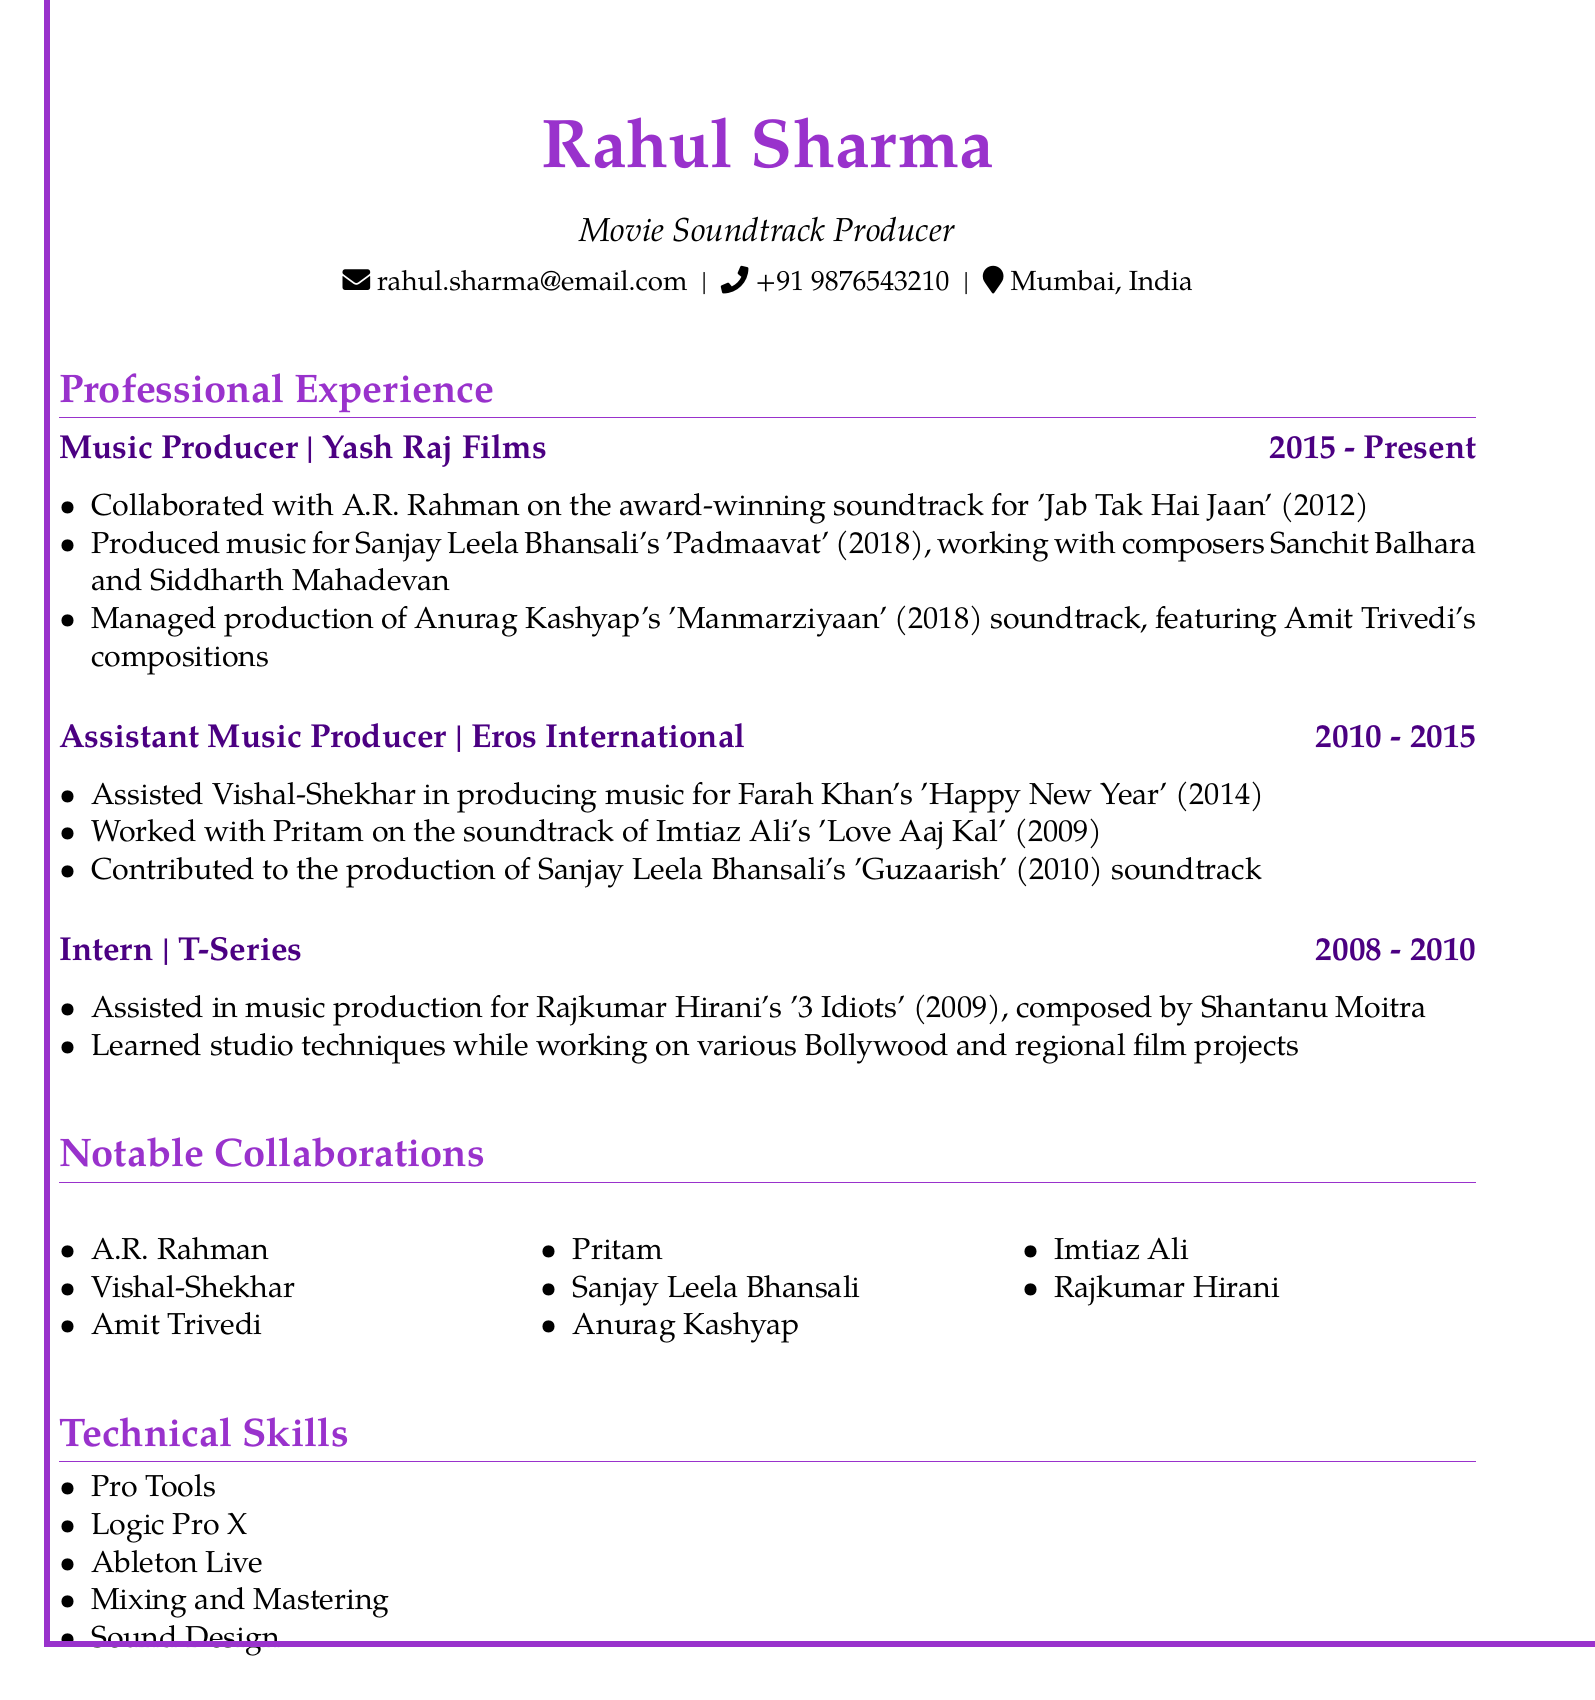What is the current position of Rahul Sharma? The current position is listed as Music Producer.
Answer: Music Producer In which company does Rahul Sharma work? The document states that he works at Yash Raj Films.
Answer: Yash Raj Films What is the duration of Rahul Sharma's role at Eros International? The document specifies the duration is from 2010 to 2015.
Answer: 2010 - 2015 Which award-winning soundtrack did Rahul collaborate on with A.R. Rahman? The document mentions 'Jab Tak Hai Jaan' as the soundtrack he worked on.
Answer: Jab Tak Hai Jaan Who composed the soundtrack for '3 Idiots'? According to the document, the composer is Shantanu Moitra.
Answer: Shantanu Moitra What notable collaboration is mentioned in the context of Sanjay Leela Bhansali? The document highlights that he collaborated with Sanjay Leela Bhansali on the soundtrack for 'Padmaavat'.
Answer: Padmaavat How many notable collaborations are listed in the document? The document lists eight notable collaborations.
Answer: Eight What software is listed as a technical skill for Rahul Sharma? The document specifies Pro Tools as one of the technical skills.
Answer: Pro Tools Which film director did Rahul work with on 'Happy New Year'? The document indicates he worked with Farah Khan on this film.
Answer: Farah Khan 